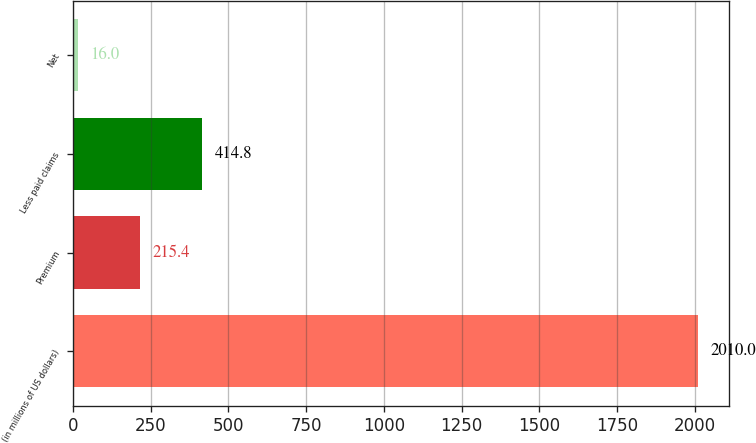Convert chart to OTSL. <chart><loc_0><loc_0><loc_500><loc_500><bar_chart><fcel>(in millions of US dollars)<fcel>Premium<fcel>Less paid claims<fcel>Net<nl><fcel>2010<fcel>215.4<fcel>414.8<fcel>16<nl></chart> 